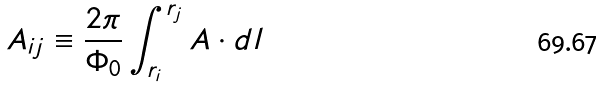Convert formula to latex. <formula><loc_0><loc_0><loc_500><loc_500>A _ { i j } \equiv \frac { 2 \pi } { \Phi _ { 0 } } \int _ { { r } _ { i } } ^ { { r } _ { j } } { A } \cdot d { l }</formula> 